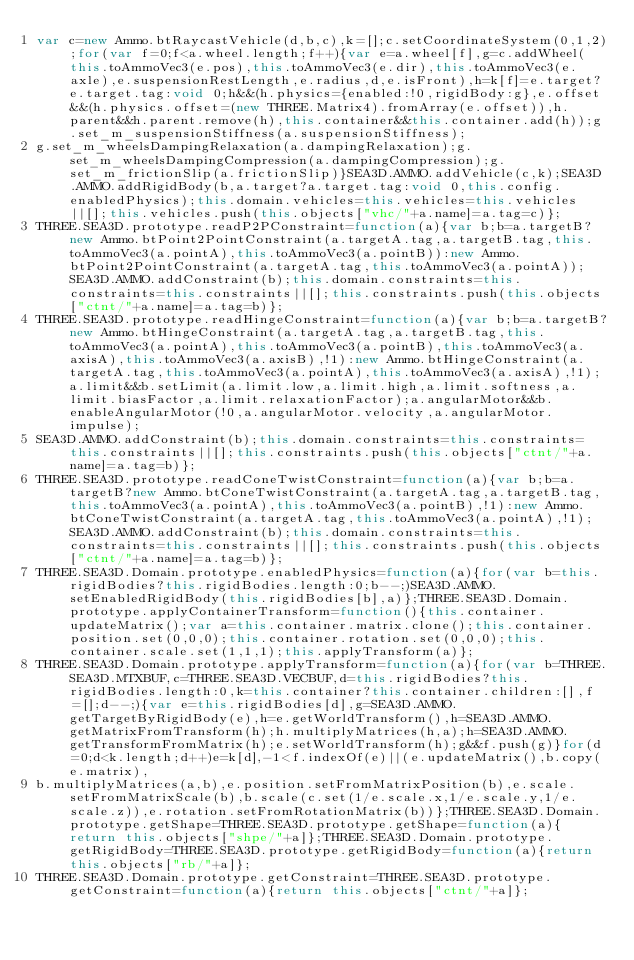Convert code to text. <code><loc_0><loc_0><loc_500><loc_500><_JavaScript_>var c=new Ammo.btRaycastVehicle(d,b,c),k=[];c.setCoordinateSystem(0,1,2);for(var f=0;f<a.wheel.length;f++){var e=a.wheel[f],g=c.addWheel(this.toAmmoVec3(e.pos),this.toAmmoVec3(e.dir),this.toAmmoVec3(e.axle),e.suspensionRestLength,e.radius,d,e.isFront),h=k[f]=e.target?e.target.tag:void 0;h&&(h.physics={enabled:!0,rigidBody:g},e.offset&&(h.physics.offset=(new THREE.Matrix4).fromArray(e.offset)),h.parent&&h.parent.remove(h),this.container&&this.container.add(h));g.set_m_suspensionStiffness(a.suspensionStiffness);
g.set_m_wheelsDampingRelaxation(a.dampingRelaxation);g.set_m_wheelsDampingCompression(a.dampingCompression);g.set_m_frictionSlip(a.frictionSlip)}SEA3D.AMMO.addVehicle(c,k);SEA3D.AMMO.addRigidBody(b,a.target?a.target.tag:void 0,this.config.enabledPhysics);this.domain.vehicles=this.vehicles=this.vehicles||[];this.vehicles.push(this.objects["vhc/"+a.name]=a.tag=c)};
THREE.SEA3D.prototype.readP2PConstraint=function(a){var b;b=a.targetB?new Ammo.btPoint2PointConstraint(a.targetA.tag,a.targetB.tag,this.toAmmoVec3(a.pointA),this.toAmmoVec3(a.pointB)):new Ammo.btPoint2PointConstraint(a.targetA.tag,this.toAmmoVec3(a.pointA));SEA3D.AMMO.addConstraint(b);this.domain.constraints=this.constraints=this.constraints||[];this.constraints.push(this.objects["ctnt/"+a.name]=a.tag=b)};
THREE.SEA3D.prototype.readHingeConstraint=function(a){var b;b=a.targetB?new Ammo.btHingeConstraint(a.targetA.tag,a.targetB.tag,this.toAmmoVec3(a.pointA),this.toAmmoVec3(a.pointB),this.toAmmoVec3(a.axisA),this.toAmmoVec3(a.axisB),!1):new Ammo.btHingeConstraint(a.targetA.tag,this.toAmmoVec3(a.pointA),this.toAmmoVec3(a.axisA),!1);a.limit&&b.setLimit(a.limit.low,a.limit.high,a.limit.softness,a.limit.biasFactor,a.limit.relaxationFactor);a.angularMotor&&b.enableAngularMotor(!0,a.angularMotor.velocity,a.angularMotor.impulse);
SEA3D.AMMO.addConstraint(b);this.domain.constraints=this.constraints=this.constraints||[];this.constraints.push(this.objects["ctnt/"+a.name]=a.tag=b)};
THREE.SEA3D.prototype.readConeTwistConstraint=function(a){var b;b=a.targetB?new Ammo.btConeTwistConstraint(a.targetA.tag,a.targetB.tag,this.toAmmoVec3(a.pointA),this.toAmmoVec3(a.pointB),!1):new Ammo.btConeTwistConstraint(a.targetA.tag,this.toAmmoVec3(a.pointA),!1);SEA3D.AMMO.addConstraint(b);this.domain.constraints=this.constraints=this.constraints||[];this.constraints.push(this.objects["ctnt/"+a.name]=a.tag=b)};
THREE.SEA3D.Domain.prototype.enabledPhysics=function(a){for(var b=this.rigidBodies?this.rigidBodies.length:0;b--;)SEA3D.AMMO.setEnabledRigidBody(this.rigidBodies[b],a)};THREE.SEA3D.Domain.prototype.applyContainerTransform=function(){this.container.updateMatrix();var a=this.container.matrix.clone();this.container.position.set(0,0,0);this.container.rotation.set(0,0,0);this.container.scale.set(1,1,1);this.applyTransform(a)};
THREE.SEA3D.Domain.prototype.applyTransform=function(a){for(var b=THREE.SEA3D.MTXBUF,c=THREE.SEA3D.VECBUF,d=this.rigidBodies?this.rigidBodies.length:0,k=this.container?this.container.children:[],f=[];d--;){var e=this.rigidBodies[d],g=SEA3D.AMMO.getTargetByRigidBody(e),h=e.getWorldTransform(),h=SEA3D.AMMO.getMatrixFromTransform(h);h.multiplyMatrices(h,a);h=SEA3D.AMMO.getTransformFromMatrix(h);e.setWorldTransform(h);g&&f.push(g)}for(d=0;d<k.length;d++)e=k[d],-1<f.indexOf(e)||(e.updateMatrix(),b.copy(e.matrix),
b.multiplyMatrices(a,b),e.position.setFromMatrixPosition(b),e.scale.setFromMatrixScale(b),b.scale(c.set(1/e.scale.x,1/e.scale.y,1/e.scale.z)),e.rotation.setFromRotationMatrix(b))};THREE.SEA3D.Domain.prototype.getShape=THREE.SEA3D.prototype.getShape=function(a){return this.objects["shpe/"+a]};THREE.SEA3D.Domain.prototype.getRigidBody=THREE.SEA3D.prototype.getRigidBody=function(a){return this.objects["rb/"+a]};
THREE.SEA3D.Domain.prototype.getConstraint=THREE.SEA3D.prototype.getConstraint=function(a){return this.objects["ctnt/"+a]};</code> 